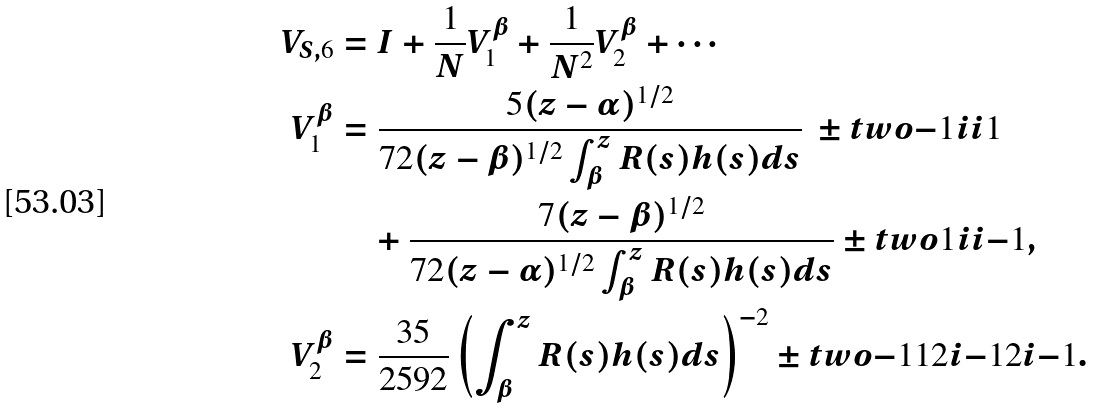<formula> <loc_0><loc_0><loc_500><loc_500>V _ { S , 6 } & = I + \frac { 1 } { N } V ^ { \beta } _ { 1 } + \frac { 1 } { N ^ { 2 } } V ^ { \beta } _ { 2 } + \cdots \\ V _ { 1 } ^ { \beta } & = \frac { 5 ( z - \alpha ) ^ { 1 / 2 } } { 7 2 ( z - \beta ) ^ { 1 / 2 } \int _ { \beta } ^ { z } R ( s ) h ( s ) d s } \ \pm t w o { - 1 } { i } { i } { 1 } \\ & \quad + \frac { 7 ( z - \beta ) ^ { 1 / 2 } } { 7 2 ( z - \alpha ) ^ { 1 / 2 } \int _ { \beta } ^ { z } R ( s ) h ( s ) d s } \pm t w o { 1 } { i } { i } { - 1 } , \\ V _ { 2 } ^ { \beta } & = \frac { 3 5 } { 2 5 9 2 } \left ( \int _ { \beta } ^ { z } R ( s ) h ( s ) d s \right ) ^ { - 2 } \pm t w o { - 1 } { 1 2 i } { - 1 2 i } { - 1 } .</formula> 